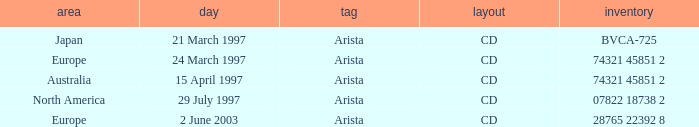What Date has the Region Europe and a Catalog of 74321 45851 2? 24 March 1997. 